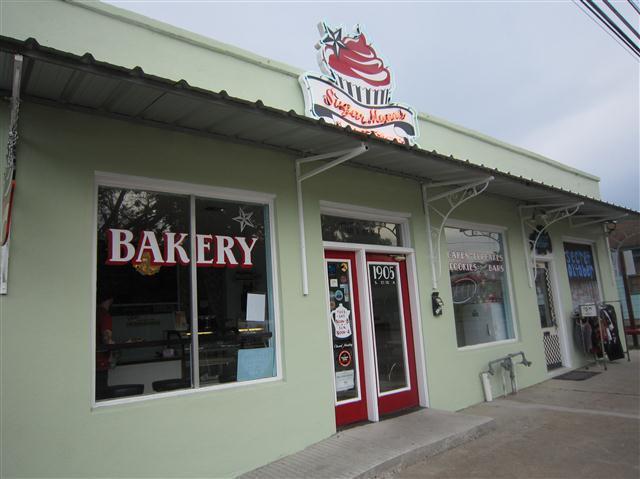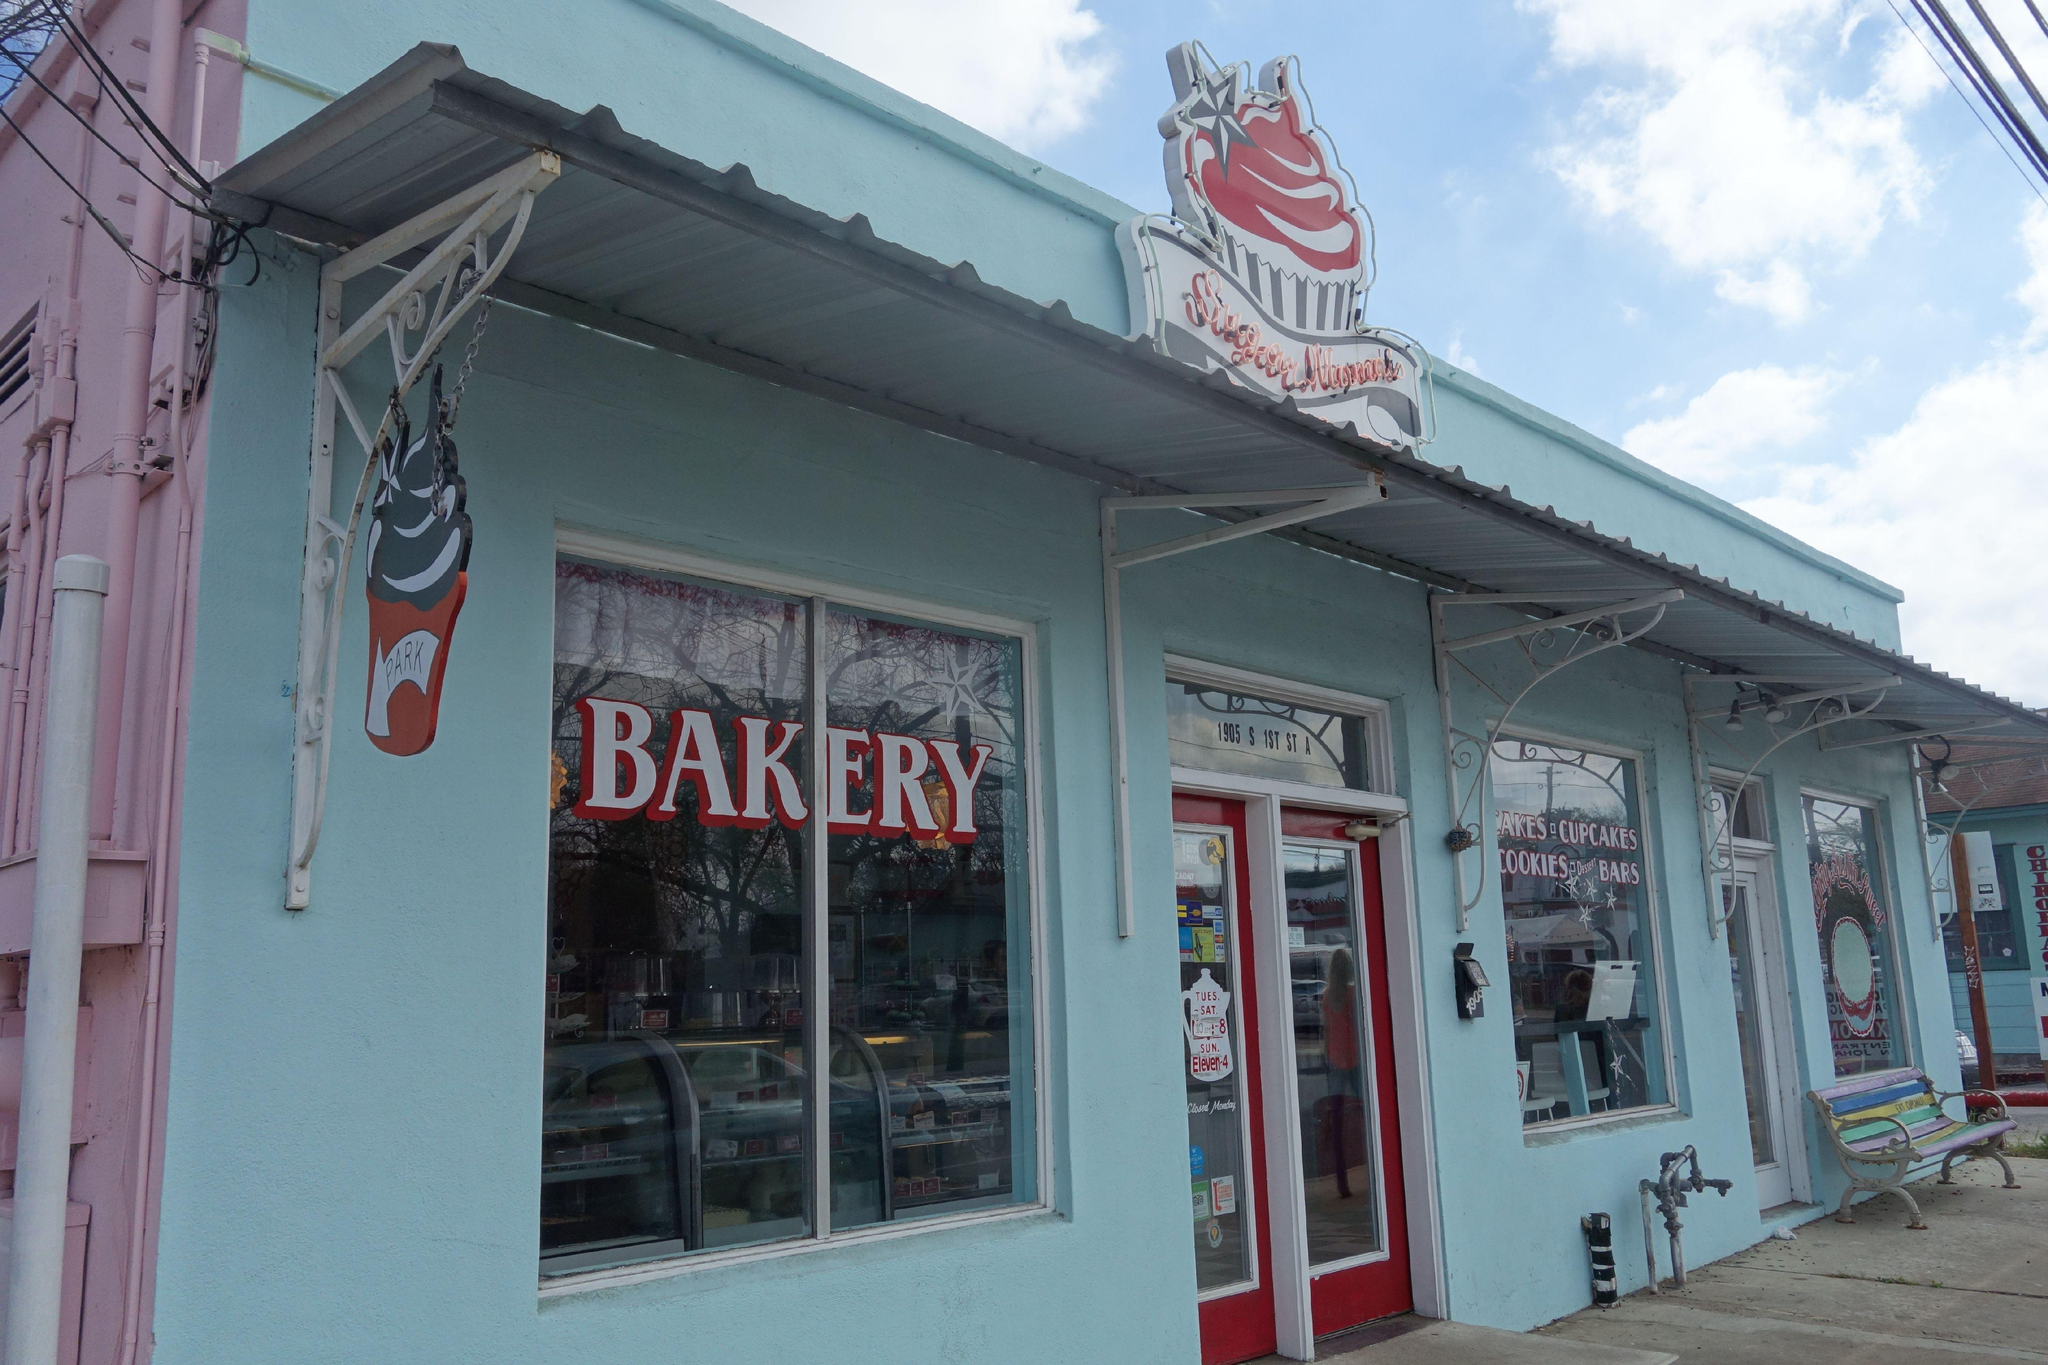The first image is the image on the left, the second image is the image on the right. Assess this claim about the two images: "In one image, a bakery has a seating area with black chairs and at least one white table.". Correct or not? Answer yes or no. No. The first image is the image on the left, the second image is the image on the right. Given the left and right images, does the statement "The left image is an interior featuring open-back black chairs around at least one white rectangular table on a black-and-white checkered floor." hold true? Answer yes or no. No. 